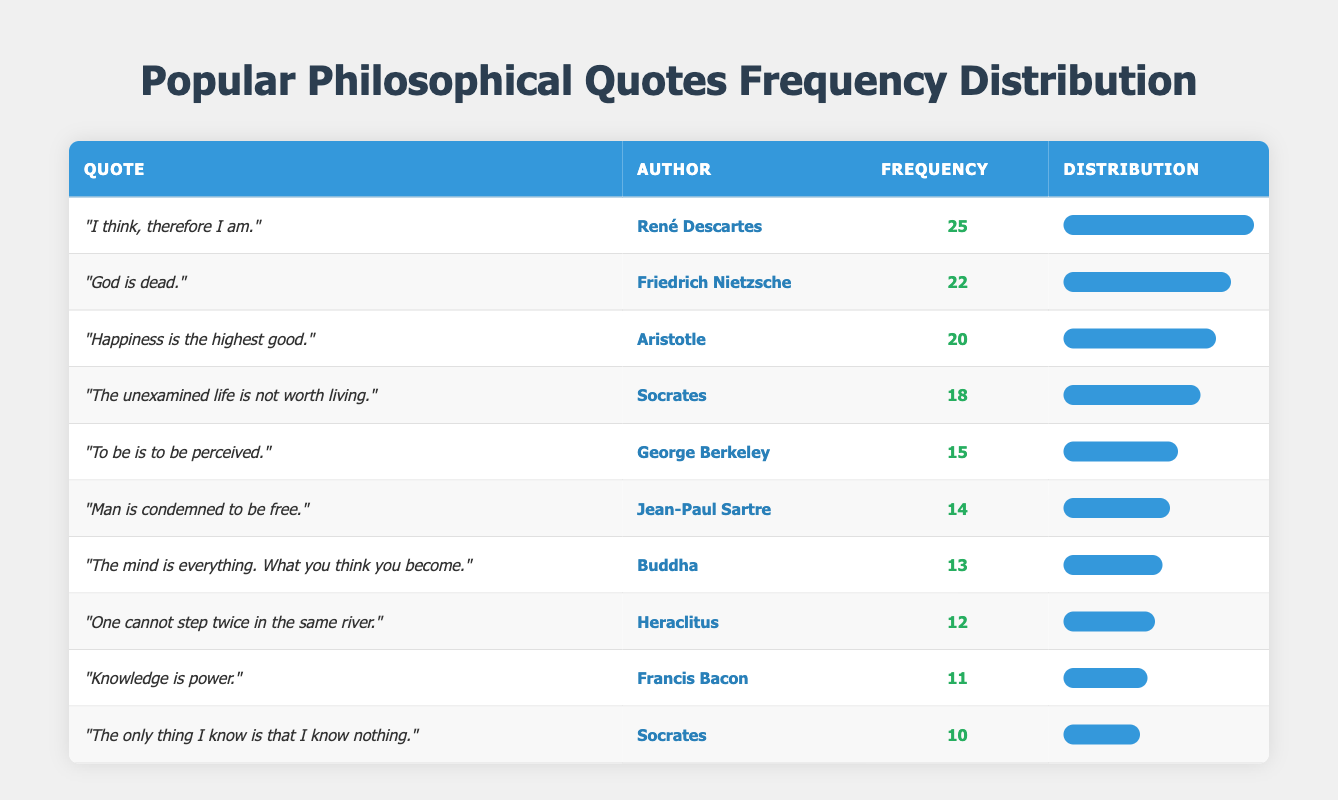What is the frequency of the quote "The unexamined life is not worth living"? The quote "The unexamined life is not worth living" is attributed to Socrates, and according to the table, its frequency is listed as 18.
Answer: 18 Which author has the highest frequency of their quotes used in academic papers? By examining the frequency column, it is clear that René Descartes has the highest frequency with 25 occurrences of his quote "I think, therefore I am."
Answer: René Descartes What is the difference in frequency between Socrates' two quotes? Socrates has one quote with a frequency of 18 ("The unexamined life is not worth living") and another with a frequency of 10 ("The only thing I know is that I know nothing"). The difference can be calculated as 18 - 10 = 8.
Answer: 8 Is "God is dead." a more popular quote than "Knowledge is power."? The frequency for "God is dead." by Friedrich Nietzsche is 22, while "Knowledge is power." by Francis Bacon has a frequency of 11. Since 22 is greater than 11, "God is dead." is indeed more popular.
Answer: Yes What is the average frequency of the quotes attributed to Socrates? Socrates has two quotes: one with a frequency of 18 and another with a frequency of 10. To find the average, we sum these frequencies (18 + 10 = 28) and divide by the number of quotes (2), resulting in an average frequency of 28 / 2 = 14.
Answer: 14 Which quote has a frequency closest to the median frequency of all the quotes in the table? To find the median, the frequencies must be listed in order: 10, 11, 12, 13, 14, 15, 18, 20, 22, 25. The middle frequencies are 14 and 15 (there are ten values), so the median is (14 + 15) / 2 = 14.5. The quote with frequency closest to this median is "Man is condemned to be free." with frequency 14.
Answer: Man is condemned to be free What is the total frequency of all quotes in the table? To find the total frequency, sum up all the frequencies: 25 + 18 + 15 + 22 + 20 + 10 + 14 + 12 + 11 + 13 =  25 + 18 = 43; 43 + 15 = 58; 58 + 22 = 80; 80 + 20 = 100; 100 + 10 = 110; 110 + 14 = 124; 124 + 12 = 136; 136 + 11 = 147; 147 + 13 = 160. The total frequency of all quotes is therefore 160.
Answer: 160 Does any quote mention the concept of freedom? Among the quotes, "Man is condemned to be free." by Jean-Paul Sartre explicitly mentions the concept of freedom. Therefore, there is a quote that reflects this idea.
Answer: Yes 